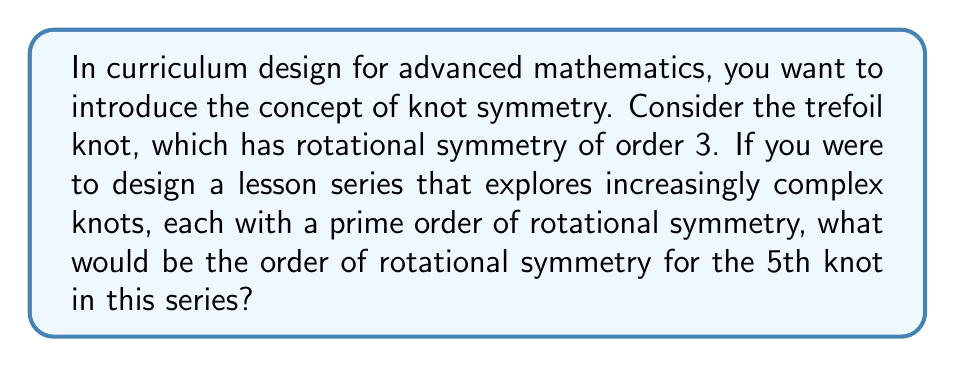Can you answer this question? Let's approach this step-by-step:

1) We start with the trefoil knot, which has rotational symmetry of order 3.

2) We're told that each subsequent knot in the series has a prime order of rotational symmetry.

3) The prime numbers in order are: 2, 3, 5, 7, 11, 13, 17, 19, 23, ...

4) However, we can't use 2 as it's less than 3 (our starting point with the trefoil knot).

5) So, our series of knots would have the following orders of rotational symmetry:
   - 1st knot (trefoil): 3
   - 2nd knot: 5
   - 3rd knot: 7
   - 4th knot: 11
   - 5th knot: 13

6) Therefore, the 5th knot in the series would have a rotational symmetry of order 13.

This progression allows for a curriculum that gradually introduces more complex symmetries, building on the foundational concept established with the trefoil knot.
Answer: 13 